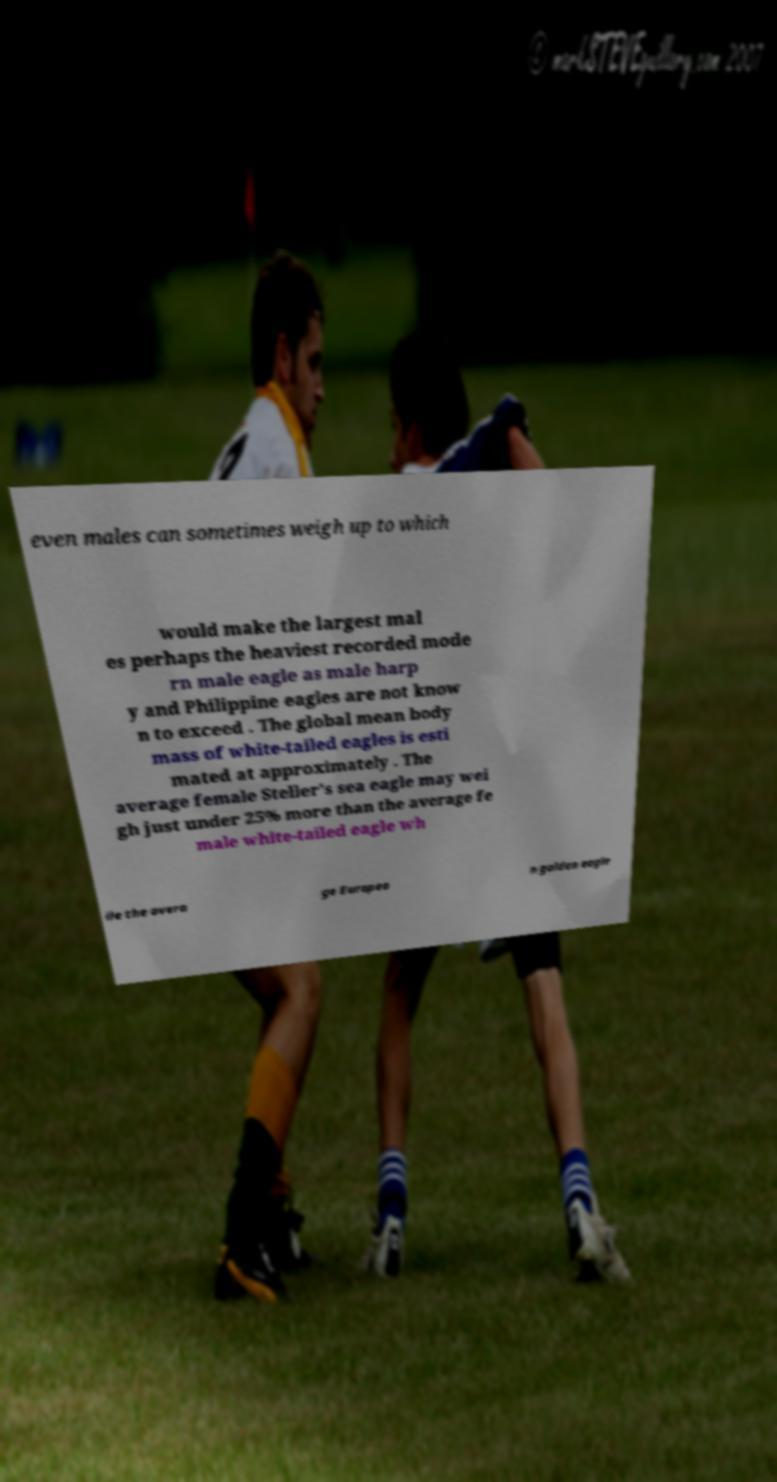Could you extract and type out the text from this image? even males can sometimes weigh up to which would make the largest mal es perhaps the heaviest recorded mode rn male eagle as male harp y and Philippine eagles are not know n to exceed . The global mean body mass of white-tailed eagles is esti mated at approximately . The average female Steller's sea eagle may wei gh just under 25% more than the average fe male white-tailed eagle wh ile the avera ge Europea n golden eagle 